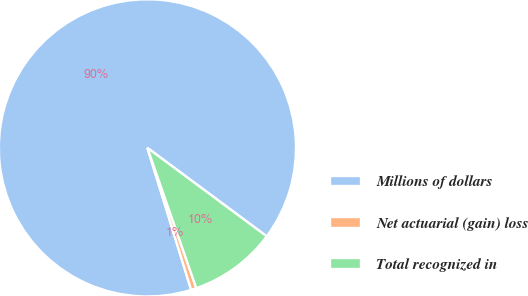Convert chart. <chart><loc_0><loc_0><loc_500><loc_500><pie_chart><fcel>Millions of dollars<fcel>Net actuarial (gain) loss<fcel>Total recognized in<nl><fcel>89.9%<fcel>0.58%<fcel>9.51%<nl></chart> 